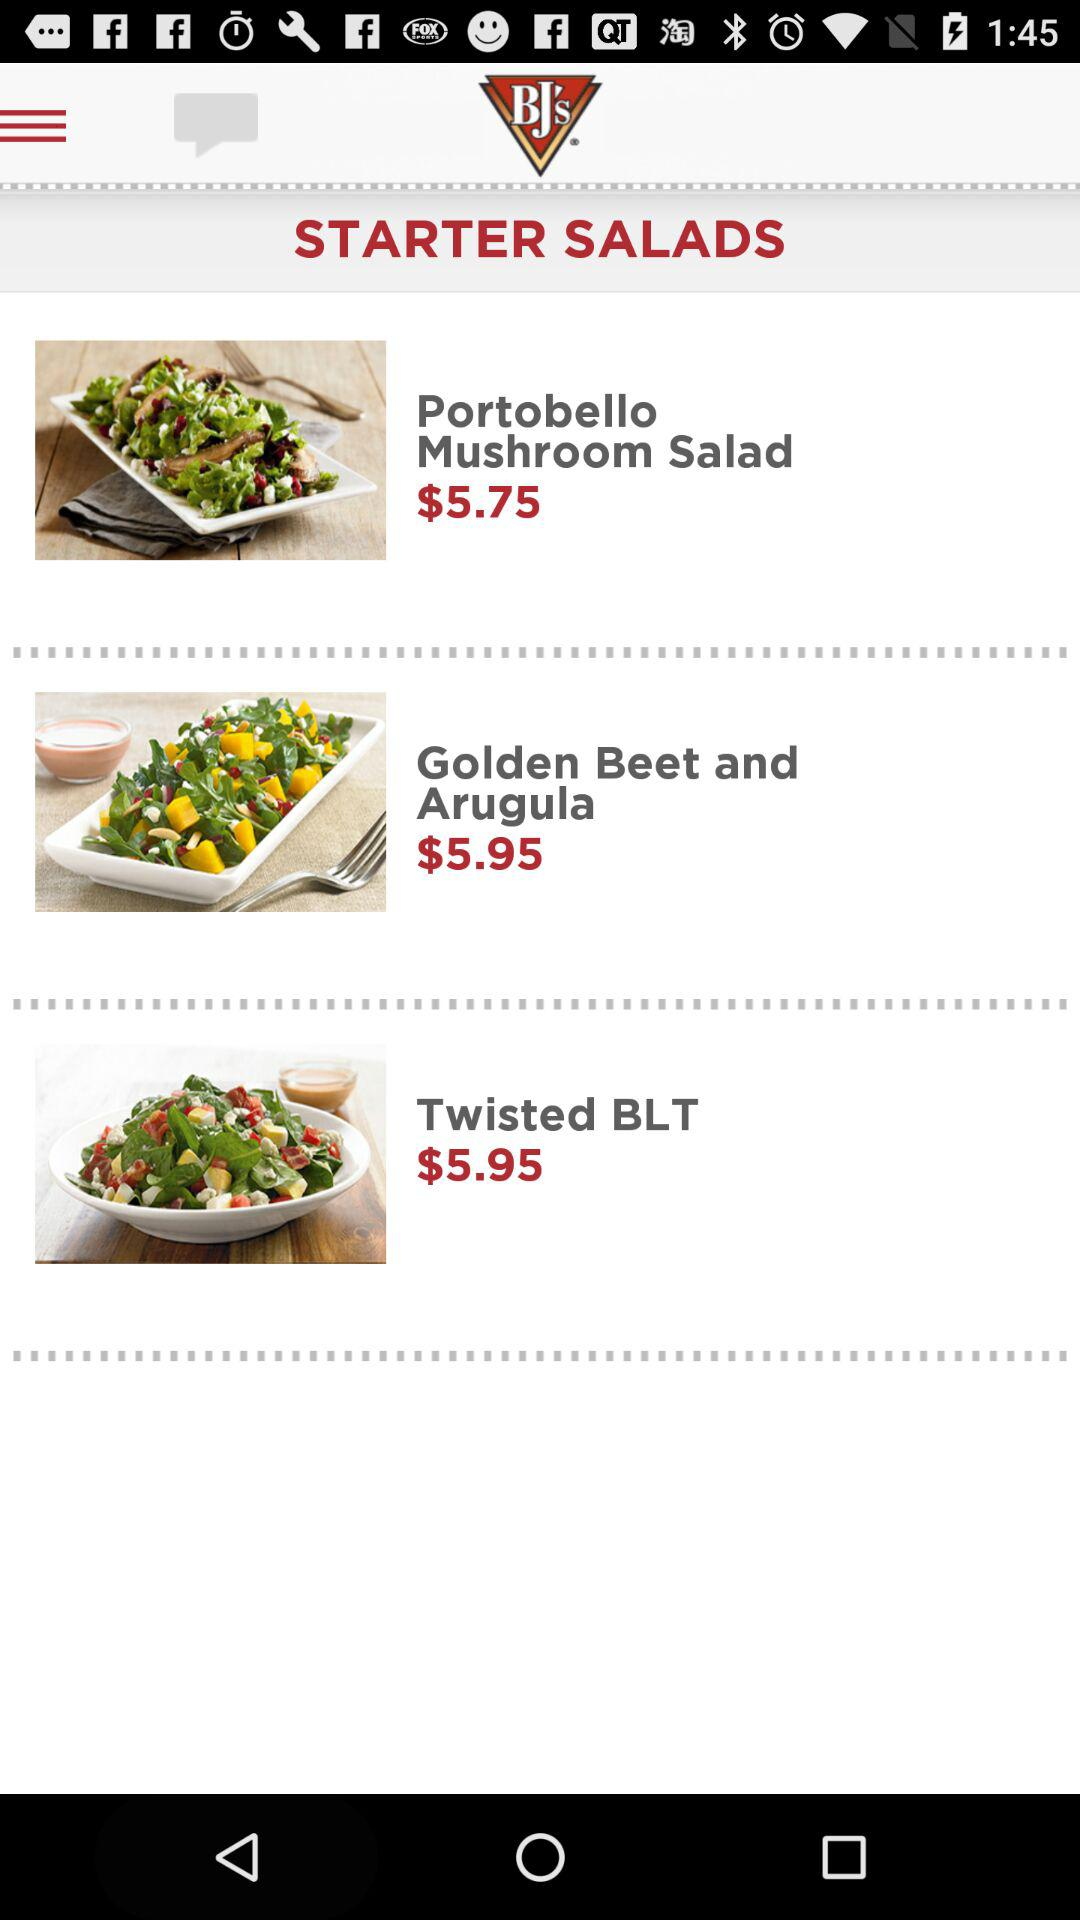What is the price of the "Twisted BLT"? The price of the "Twisted BLT" is $5.95. 